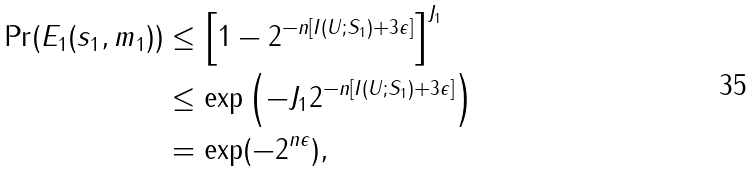Convert formula to latex. <formula><loc_0><loc_0><loc_500><loc_500>\Pr ( E _ { 1 } ( s _ { 1 } , m _ { 1 } ) ) & \leq \left [ 1 - 2 ^ { - n [ I ( U ; S _ { 1 } ) + 3 \epsilon ] } \right ] ^ { J _ { 1 } } \\ & \leq \exp \left ( - J _ { 1 } 2 ^ { - n [ I ( U ; S _ { 1 } ) + 3 \epsilon ] } \right ) \\ & = \exp ( - 2 ^ { n \epsilon } ) ,</formula> 